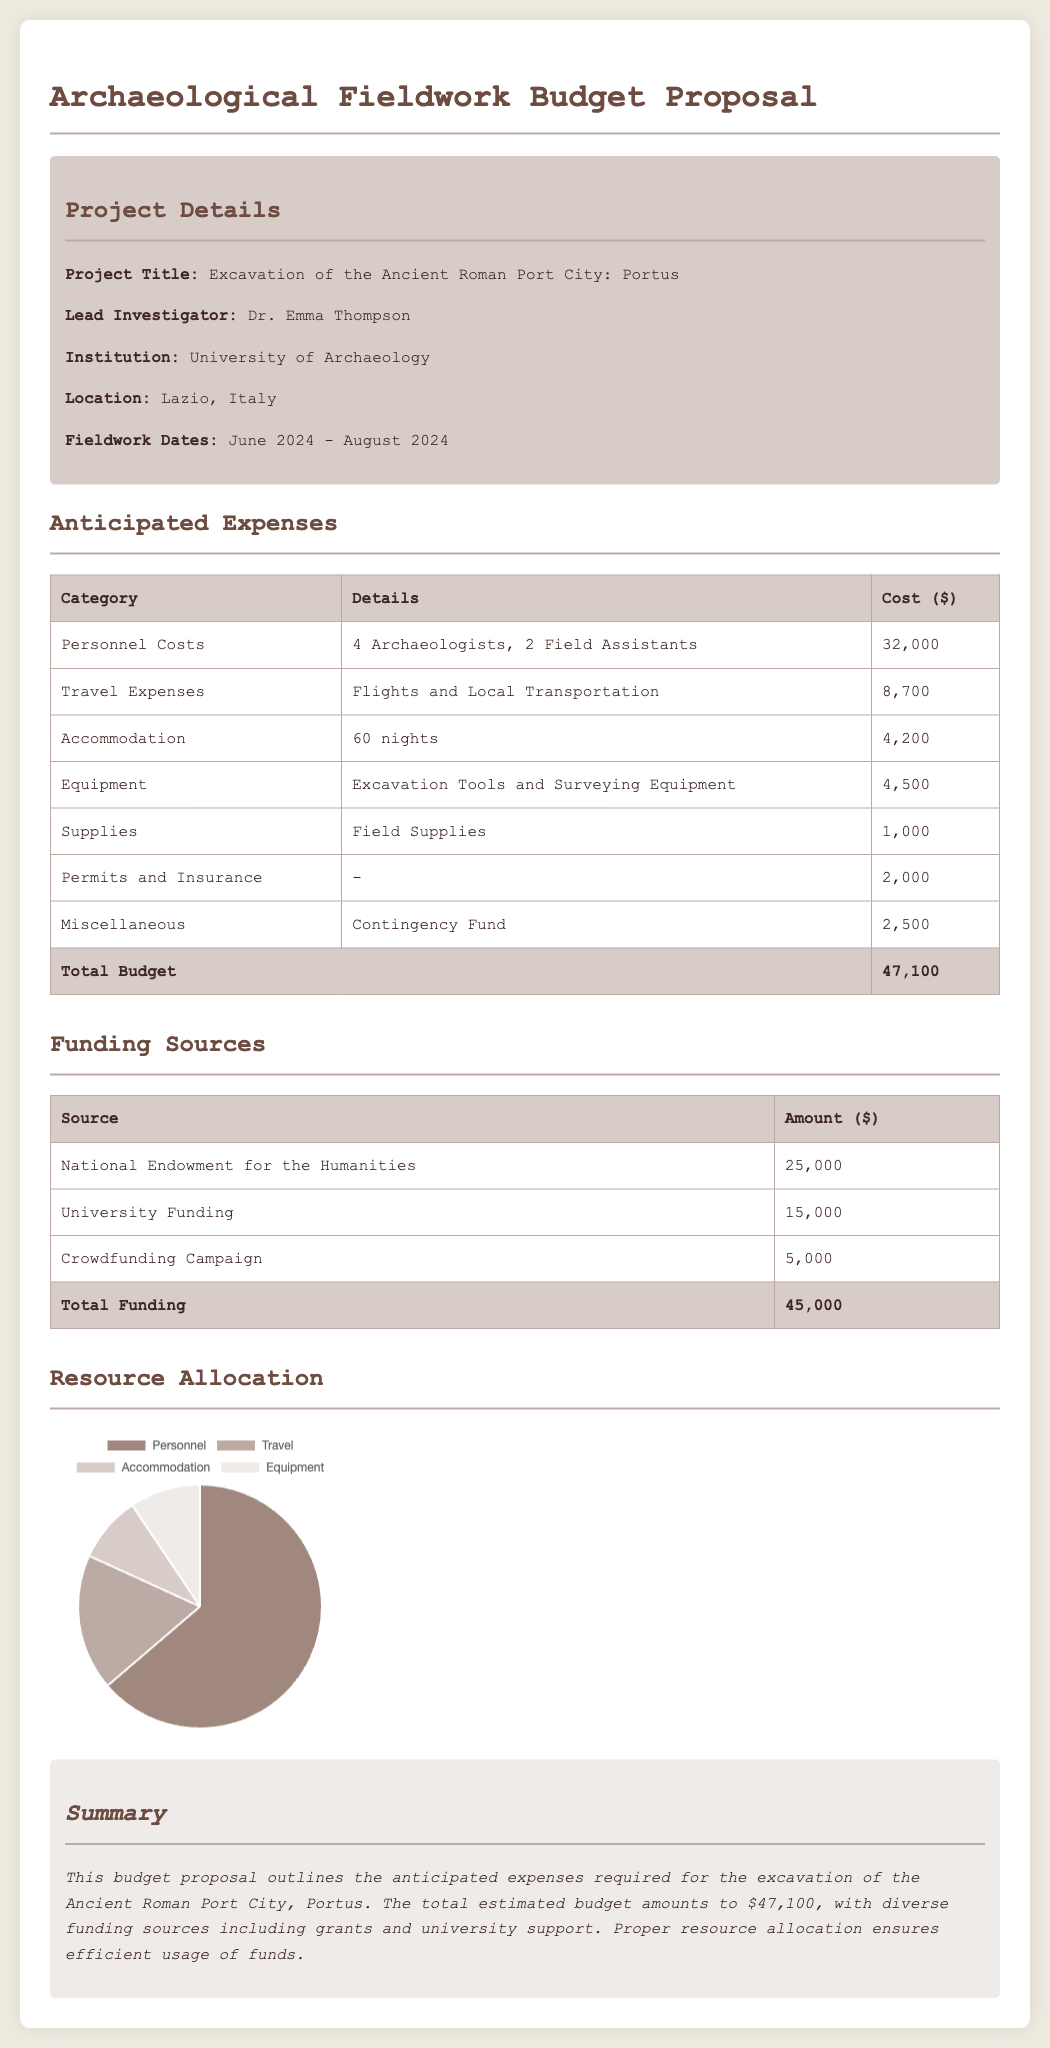What is the project title? The project title is clearly stated in the document under "Project Details".
Answer: Excavation of the Ancient Roman Port City: Portus Who is the lead investigator? The lead investigator's name is specified in the same section.
Answer: Dr. Emma Thompson What is the total estimated budget? The total estimated budget is found as the last entry in the anticipated expenses table.
Answer: 47,100 How many archaeologists are part of the personnel costs? The number of archaeologists is listed in the details of the personnel costs.
Answer: 4 Archaeologists What is the amount received from the National Endowment for the Humanities? The amount received can be found in the funding sources section.
Answer: 25,000 What percentage of the budget is allocated for accommodation based on the chart? The percentage allocation for accommodation is derived from the data represented in the resource allocation chart.
Answer: 8.9 What is the funding source with the smallest amount? The funding sources listed are specific in the funding table.
Answer: Crowdfunding Campaign Which institution is leading the fieldwork proposal? The institution is mentioned within the project details section of the document.
Answer: University of Archaeology What is the duration of the fieldwork? The duration is specified under fieldwork dates in the project details section.
Answer: June 2024 - August 2024 